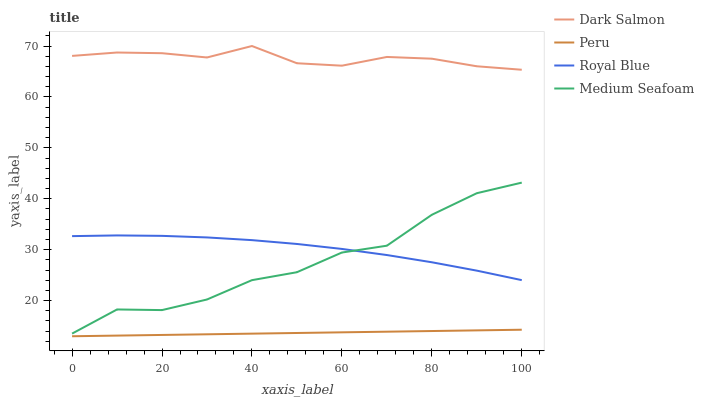Does Dark Salmon have the minimum area under the curve?
Answer yes or no. No. Does Peru have the maximum area under the curve?
Answer yes or no. No. Is Dark Salmon the smoothest?
Answer yes or no. No. Is Dark Salmon the roughest?
Answer yes or no. No. Does Dark Salmon have the lowest value?
Answer yes or no. No. Does Peru have the highest value?
Answer yes or no. No. Is Royal Blue less than Dark Salmon?
Answer yes or no. Yes. Is Dark Salmon greater than Medium Seafoam?
Answer yes or no. Yes. Does Royal Blue intersect Dark Salmon?
Answer yes or no. No. 